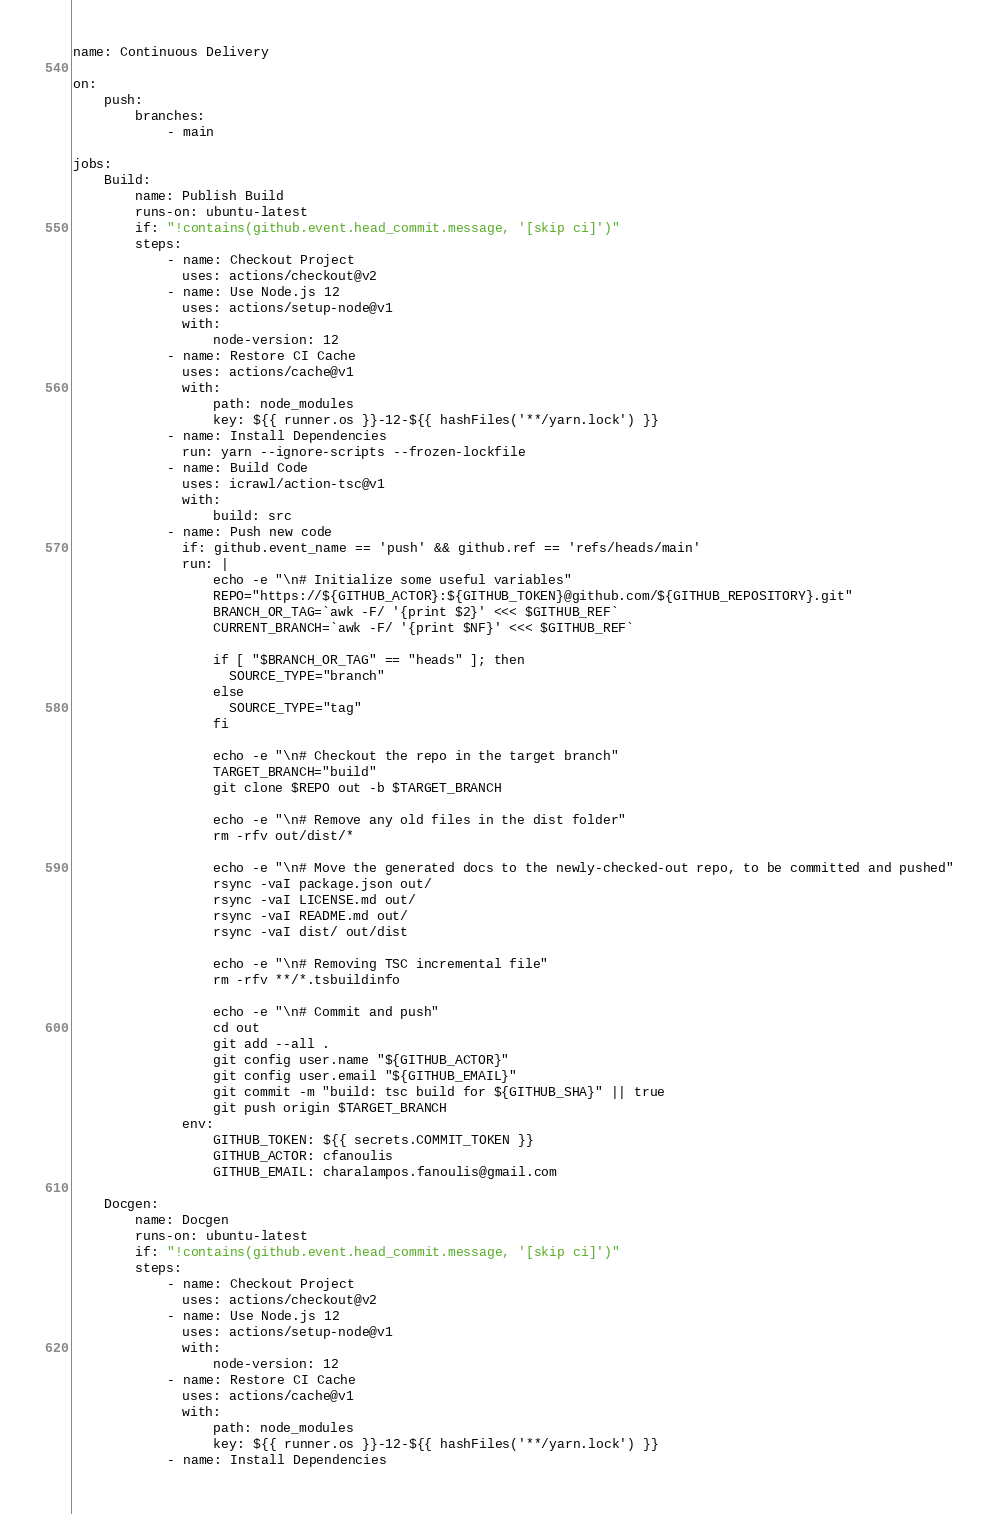Convert code to text. <code><loc_0><loc_0><loc_500><loc_500><_YAML_>name: Continuous Delivery

on:
    push:
        branches:
            - main

jobs:
    Build:
        name: Publish Build
        runs-on: ubuntu-latest
        if: "!contains(github.event.head_commit.message, '[skip ci]')"
        steps:
            - name: Checkout Project
              uses: actions/checkout@v2
            - name: Use Node.js 12
              uses: actions/setup-node@v1
              with:
                  node-version: 12
            - name: Restore CI Cache
              uses: actions/cache@v1
              with:
                  path: node_modules
                  key: ${{ runner.os }}-12-${{ hashFiles('**/yarn.lock') }}
            - name: Install Dependencies
              run: yarn --ignore-scripts --frozen-lockfile
            - name: Build Code
              uses: icrawl/action-tsc@v1
              with:
                  build: src
            - name: Push new code
              if: github.event_name == 'push' && github.ref == 'refs/heads/main'
              run: |
                  echo -e "\n# Initialize some useful variables"
                  REPO="https://${GITHUB_ACTOR}:${GITHUB_TOKEN}@github.com/${GITHUB_REPOSITORY}.git"
                  BRANCH_OR_TAG=`awk -F/ '{print $2}' <<< $GITHUB_REF`
                  CURRENT_BRANCH=`awk -F/ '{print $NF}' <<< $GITHUB_REF`

                  if [ "$BRANCH_OR_TAG" == "heads" ]; then
                    SOURCE_TYPE="branch"
                  else
                    SOURCE_TYPE="tag"
                  fi

                  echo -e "\n# Checkout the repo in the target branch"
                  TARGET_BRANCH="build"
                  git clone $REPO out -b $TARGET_BRANCH

                  echo -e "\n# Remove any old files in the dist folder"
                  rm -rfv out/dist/*

                  echo -e "\n# Move the generated docs to the newly-checked-out repo, to be committed and pushed"
                  rsync -vaI package.json out/
                  rsync -vaI LICENSE.md out/
                  rsync -vaI README.md out/
                  rsync -vaI dist/ out/dist

                  echo -e "\n# Removing TSC incremental file"
                  rm -rfv **/*.tsbuildinfo

                  echo -e "\n# Commit and push"
                  cd out
                  git add --all .
                  git config user.name "${GITHUB_ACTOR}"
                  git config user.email "${GITHUB_EMAIL}"
                  git commit -m "build: tsc build for ${GITHUB_SHA}" || true
                  git push origin $TARGET_BRANCH
              env:
                  GITHUB_TOKEN: ${{ secrets.COMMIT_TOKEN }}
                  GITHUB_ACTOR: cfanoulis
                  GITHUB_EMAIL: charalampos.fanoulis@gmail.com

    Docgen:
        name: Docgen
        runs-on: ubuntu-latest
        if: "!contains(github.event.head_commit.message, '[skip ci]')"
        steps:
            - name: Checkout Project
              uses: actions/checkout@v2
            - name: Use Node.js 12
              uses: actions/setup-node@v1
              with:
                  node-version: 12
            - name: Restore CI Cache
              uses: actions/cache@v1
              with:
                  path: node_modules
                  key: ${{ runner.os }}-12-${{ hashFiles('**/yarn.lock') }}
            - name: Install Dependencies</code> 